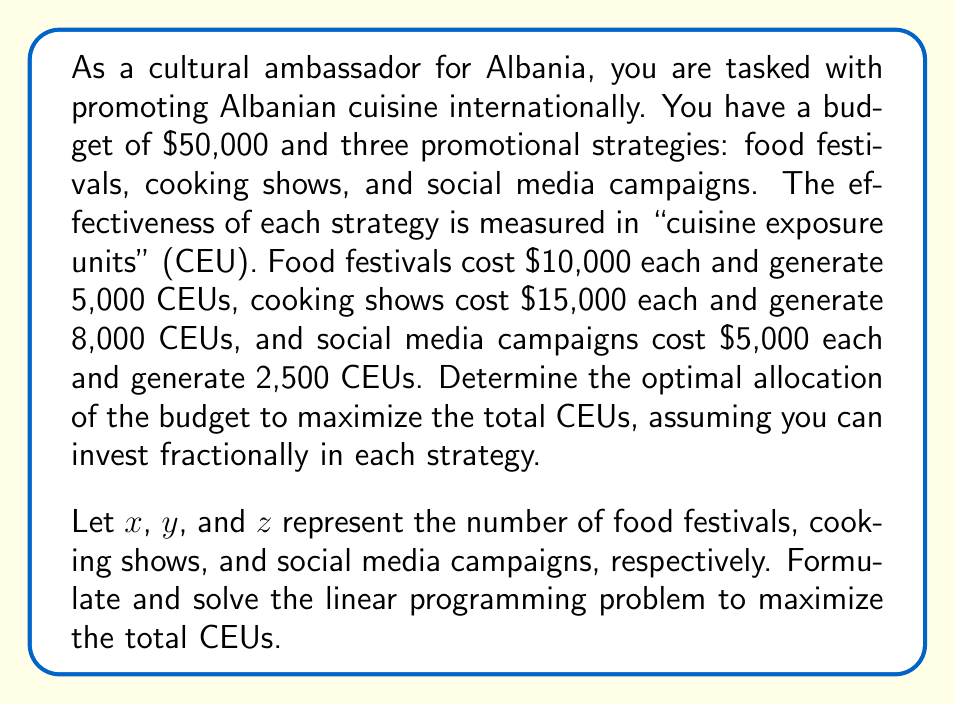Help me with this question. To solve this optimization problem, we need to formulate it as a linear programming problem and then solve it using the simplex method or another optimization technique. Let's break it down step by step:

1. Define the objective function:
   Maximize $f(x,y,z) = 5000x + 8000y + 2500z$

2. Identify the constraints:
   Budget constraint: $10000x + 15000y + 5000z \leq 50000$
   Non-negativity constraints: $x \geq 0$, $y \geq 0$, $z \geq 0$

3. Formulate the linear programming problem:
   
   Maximize $f(x,y,z) = 5000x + 8000y + 2500z$
   
   Subject to:
   $$\begin{aligned}
   10000x + 15000y + 5000z &\leq 50000 \\
   x, y, z &\geq 0
   \end{aligned}$$

4. To solve this problem, we can use the simplex method or a graphical method. In this case, we'll use the concept of return on investment (ROI) for each strategy:

   Food festivals: $5000 / 10000 = 0.5$ CEU/$
   Cooking shows: $8000 / 15000 \approx 0.533$ CEU/$
   Social media campaigns: $2500 / 5000 = 0.5$ CEU/$

5. Since cooking shows have the highest ROI, we should allocate as much budget as possible to cooking shows first.

6. Calculate the number of cooking shows we can fund:
   $50000 / 15000 = 3.333$ shows

7. We can fully fund 3 cooking shows, using $45000 of the budget.

8. The remaining $5000 can be allocated to a social media campaign, which has the same ROI as food festivals but fits within the remaining budget.

9. Calculate the total CEUs:
   $(3 \times 8000) + (1 \times 2500) = 24000 + 2500 = 26500$ CEUs

Therefore, the optimal allocation is 3 cooking shows and 1 social media campaign.
Answer: The optimal allocation to maximize total CEUs is:
$y = 3$ (cooking shows)
$z = 1$ (social media campaign)
$x = 0$ (food festivals)

This allocation yields a maximum of 26,500 CEUs. 